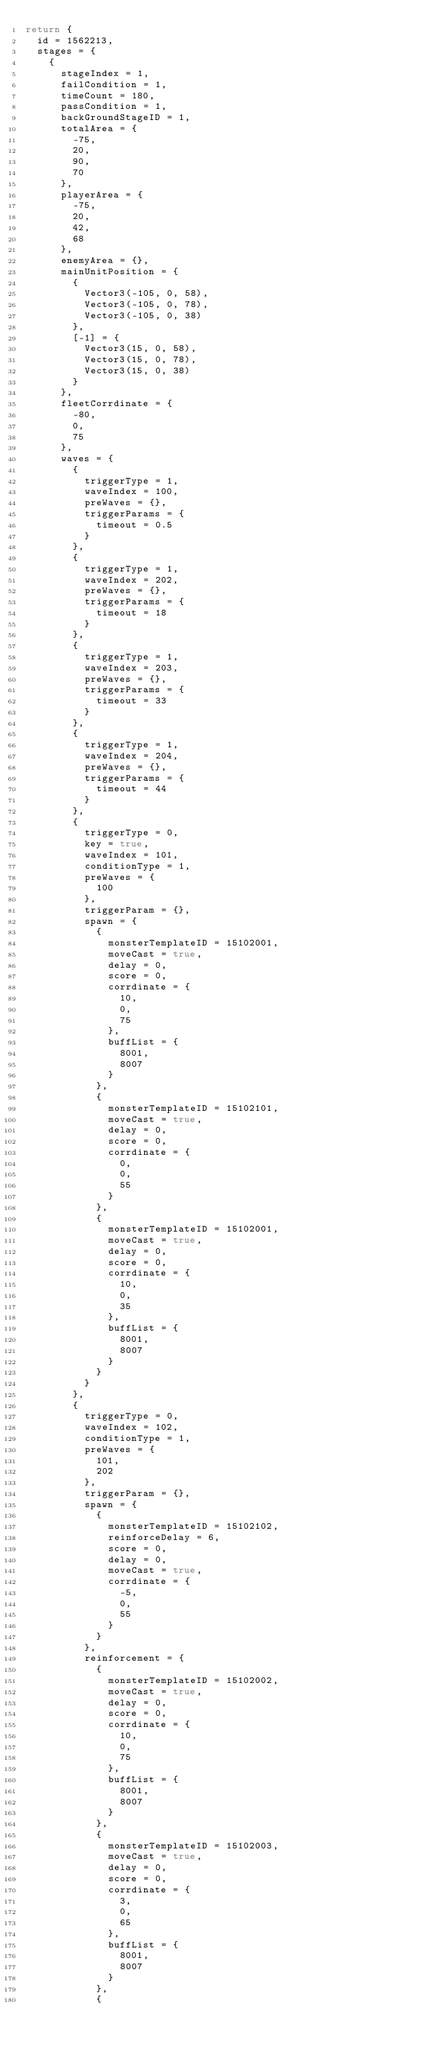Convert code to text. <code><loc_0><loc_0><loc_500><loc_500><_Lua_>return {
	id = 1562213,
	stages = {
		{
			stageIndex = 1,
			failCondition = 1,
			timeCount = 180,
			passCondition = 1,
			backGroundStageID = 1,
			totalArea = {
				-75,
				20,
				90,
				70
			},
			playerArea = {
				-75,
				20,
				42,
				68
			},
			enemyArea = {},
			mainUnitPosition = {
				{
					Vector3(-105, 0, 58),
					Vector3(-105, 0, 78),
					Vector3(-105, 0, 38)
				},
				[-1] = {
					Vector3(15, 0, 58),
					Vector3(15, 0, 78),
					Vector3(15, 0, 38)
				}
			},
			fleetCorrdinate = {
				-80,
				0,
				75
			},
			waves = {
				{
					triggerType = 1,
					waveIndex = 100,
					preWaves = {},
					triggerParams = {
						timeout = 0.5
					}
				},
				{
					triggerType = 1,
					waveIndex = 202,
					preWaves = {},
					triggerParams = {
						timeout = 18
					}
				},
				{
					triggerType = 1,
					waveIndex = 203,
					preWaves = {},
					triggerParams = {
						timeout = 33
					}
				},
				{
					triggerType = 1,
					waveIndex = 204,
					preWaves = {},
					triggerParams = {
						timeout = 44
					}
				},
				{
					triggerType = 0,
					key = true,
					waveIndex = 101,
					conditionType = 1,
					preWaves = {
						100
					},
					triggerParam = {},
					spawn = {
						{
							monsterTemplateID = 15102001,
							moveCast = true,
							delay = 0,
							score = 0,
							corrdinate = {
								10,
								0,
								75
							},
							buffList = {
								8001,
								8007
							}
						},
						{
							monsterTemplateID = 15102101,
							moveCast = true,
							delay = 0,
							score = 0,
							corrdinate = {
								0,
								0,
								55
							}
						},
						{
							monsterTemplateID = 15102001,
							moveCast = true,
							delay = 0,
							score = 0,
							corrdinate = {
								10,
								0,
								35
							},
							buffList = {
								8001,
								8007
							}
						}
					}
				},
				{
					triggerType = 0,
					waveIndex = 102,
					conditionType = 1,
					preWaves = {
						101,
						202
					},
					triggerParam = {},
					spawn = {
						{
							monsterTemplateID = 15102102,
							reinforceDelay = 6,
							score = 0,
							delay = 0,
							moveCast = true,
							corrdinate = {
								-5,
								0,
								55
							}
						}
					},
					reinforcement = {
						{
							monsterTemplateID = 15102002,
							moveCast = true,
							delay = 0,
							score = 0,
							corrdinate = {
								10,
								0,
								75
							},
							buffList = {
								8001,
								8007
							}
						},
						{
							monsterTemplateID = 15102003,
							moveCast = true,
							delay = 0,
							score = 0,
							corrdinate = {
								3,
								0,
								65
							},
							buffList = {
								8001,
								8007
							}
						},
						{</code> 